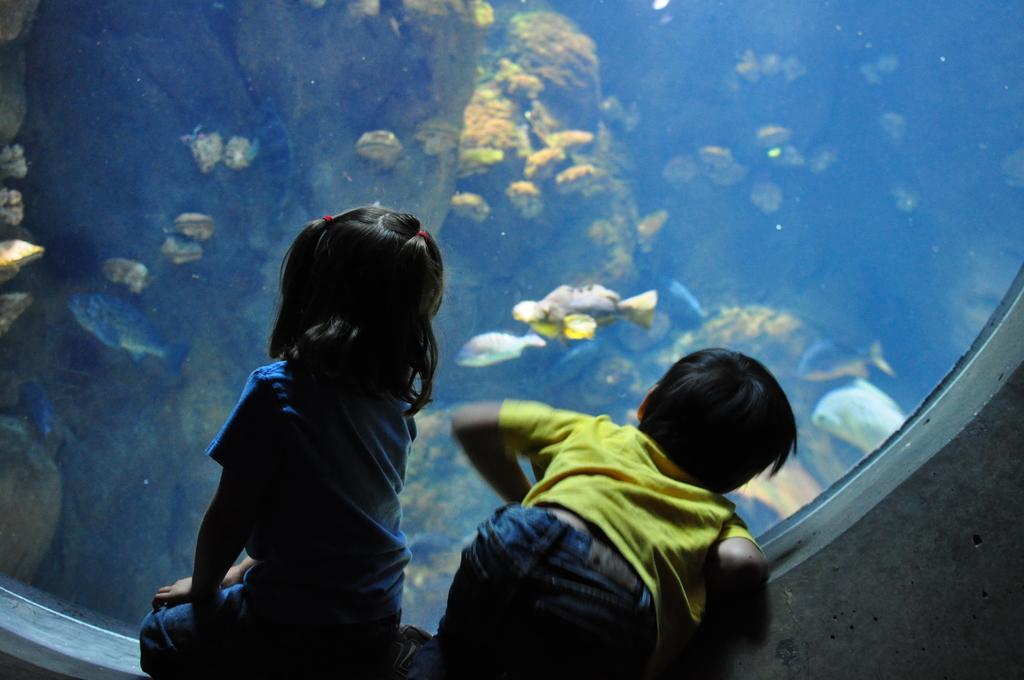How would you summarize this image in a sentence or two? Here I can see a girl and a boy are sitting on the knees and looking at the back side. In the background there is a fish tank. In that, I can see many fishes and marine species in the water. 